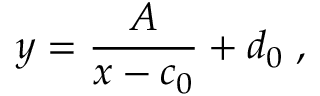Convert formula to latex. <formula><loc_0><loc_0><loc_500><loc_500>y = { \frac { A } { x - c _ { 0 } } } + d _ { 0 } \, ,</formula> 